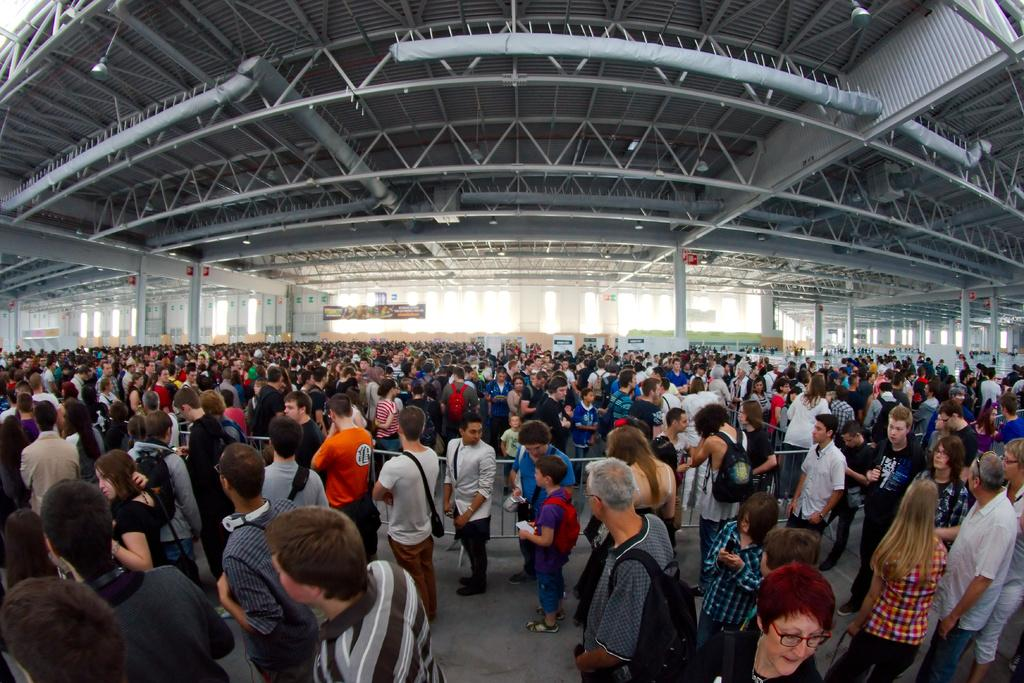What is happening on the path in the image? There are many people standing on the path in the image. What can be seen on the path to separate or guide the people? There are barricades from left to right in the image. What else is visible in the image besides the people and barricades? There are boards visible in the image. What might be used to illuminate the area in the image? There are lights on top in the image. What type of mask is being worn by the person in the image? There are no people wearing masks in the image. What kind of ring can be seen on the finger of the person in the image? There are no rings visible on any person's finger in the image. 